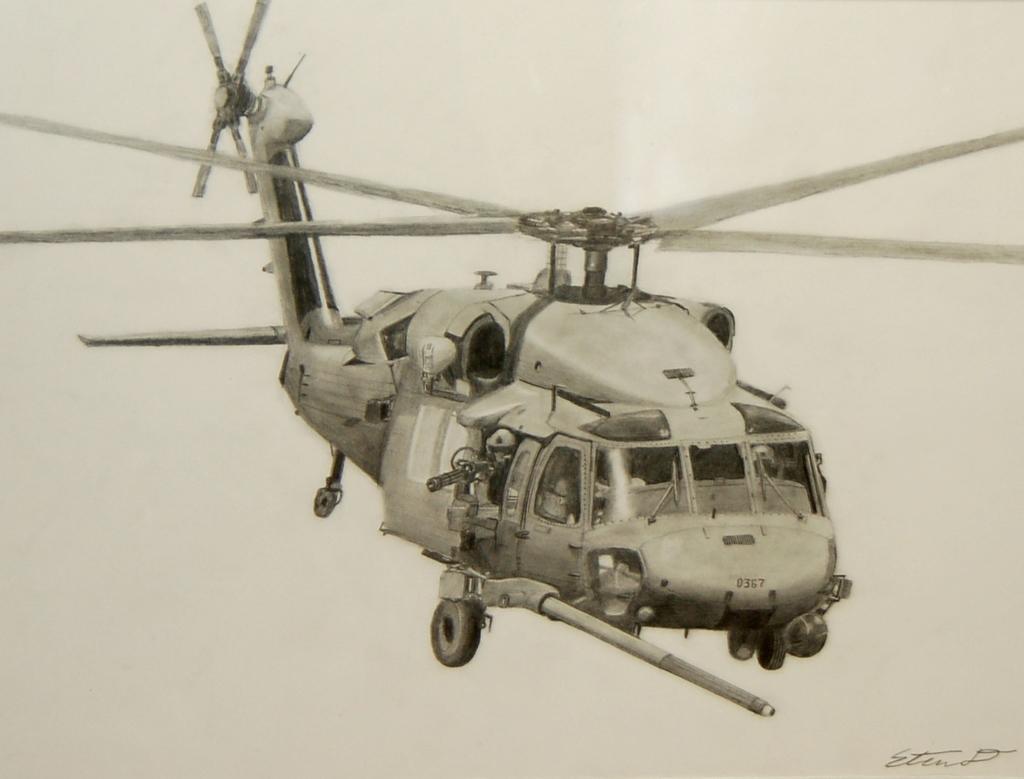Can you describe this image briefly? In this image I can see a helicopter and here I can see few numbers are written. I can also see this image is black and white in colour. 